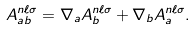Convert formula to latex. <formula><loc_0><loc_0><loc_500><loc_500>A ^ { n \ell \sigma } _ { a b } = \nabla _ { a } A ^ { n \ell \sigma } _ { b } + \nabla _ { b } A ^ { n \ell \sigma } _ { a } .</formula> 